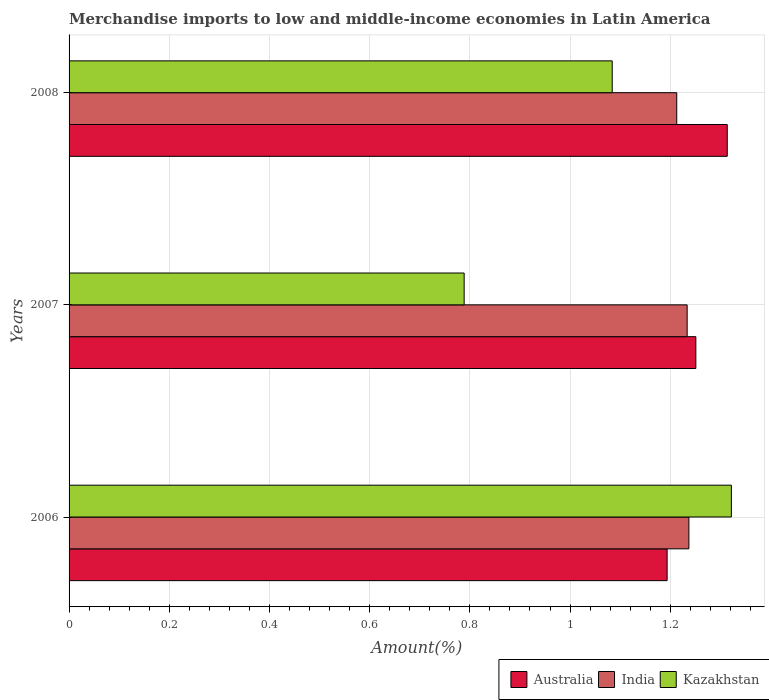How many different coloured bars are there?
Keep it short and to the point. 3. How many groups of bars are there?
Give a very brief answer. 3. Are the number of bars on each tick of the Y-axis equal?
Provide a short and direct response. Yes. How many bars are there on the 1st tick from the top?
Ensure brevity in your answer.  3. How many bars are there on the 2nd tick from the bottom?
Offer a very short reply. 3. In how many cases, is the number of bars for a given year not equal to the number of legend labels?
Keep it short and to the point. 0. What is the percentage of amount earned from merchandise imports in India in 2008?
Your answer should be compact. 1.21. Across all years, what is the maximum percentage of amount earned from merchandise imports in Kazakhstan?
Your response must be concise. 1.32. Across all years, what is the minimum percentage of amount earned from merchandise imports in Australia?
Offer a very short reply. 1.19. In which year was the percentage of amount earned from merchandise imports in Australia minimum?
Provide a succinct answer. 2006. What is the total percentage of amount earned from merchandise imports in Australia in the graph?
Ensure brevity in your answer.  3.76. What is the difference between the percentage of amount earned from merchandise imports in Kazakhstan in 2006 and that in 2008?
Provide a succinct answer. 0.24. What is the difference between the percentage of amount earned from merchandise imports in Australia in 2008 and the percentage of amount earned from merchandise imports in India in 2007?
Your answer should be compact. 0.08. What is the average percentage of amount earned from merchandise imports in Kazakhstan per year?
Ensure brevity in your answer.  1.06. In the year 2008, what is the difference between the percentage of amount earned from merchandise imports in Australia and percentage of amount earned from merchandise imports in Kazakhstan?
Offer a very short reply. 0.23. What is the ratio of the percentage of amount earned from merchandise imports in Kazakhstan in 2006 to that in 2007?
Provide a short and direct response. 1.68. Is the difference between the percentage of amount earned from merchandise imports in Australia in 2007 and 2008 greater than the difference between the percentage of amount earned from merchandise imports in Kazakhstan in 2007 and 2008?
Provide a short and direct response. Yes. What is the difference between the highest and the second highest percentage of amount earned from merchandise imports in Australia?
Provide a short and direct response. 0.06. What is the difference between the highest and the lowest percentage of amount earned from merchandise imports in Kazakhstan?
Your answer should be very brief. 0.53. What does the 3rd bar from the top in 2008 represents?
Your response must be concise. Australia. Does the graph contain any zero values?
Offer a terse response. No. Does the graph contain grids?
Give a very brief answer. Yes. Where does the legend appear in the graph?
Make the answer very short. Bottom right. How are the legend labels stacked?
Offer a terse response. Horizontal. What is the title of the graph?
Your answer should be very brief. Merchandise imports to low and middle-income economies in Latin America. What is the label or title of the X-axis?
Provide a succinct answer. Amount(%). What is the label or title of the Y-axis?
Ensure brevity in your answer.  Years. What is the Amount(%) in Australia in 2006?
Offer a very short reply. 1.19. What is the Amount(%) of India in 2006?
Offer a terse response. 1.24. What is the Amount(%) in Kazakhstan in 2006?
Ensure brevity in your answer.  1.32. What is the Amount(%) in Australia in 2007?
Your answer should be compact. 1.25. What is the Amount(%) of India in 2007?
Your answer should be compact. 1.23. What is the Amount(%) of Kazakhstan in 2007?
Offer a very short reply. 0.79. What is the Amount(%) of Australia in 2008?
Give a very brief answer. 1.31. What is the Amount(%) in India in 2008?
Your answer should be very brief. 1.21. What is the Amount(%) of Kazakhstan in 2008?
Offer a terse response. 1.08. Across all years, what is the maximum Amount(%) in Australia?
Your answer should be compact. 1.31. Across all years, what is the maximum Amount(%) in India?
Provide a succinct answer. 1.24. Across all years, what is the maximum Amount(%) of Kazakhstan?
Ensure brevity in your answer.  1.32. Across all years, what is the minimum Amount(%) of Australia?
Ensure brevity in your answer.  1.19. Across all years, what is the minimum Amount(%) of India?
Provide a succinct answer. 1.21. Across all years, what is the minimum Amount(%) in Kazakhstan?
Give a very brief answer. 0.79. What is the total Amount(%) in Australia in the graph?
Keep it short and to the point. 3.76. What is the total Amount(%) in India in the graph?
Keep it short and to the point. 3.68. What is the total Amount(%) in Kazakhstan in the graph?
Your answer should be compact. 3.19. What is the difference between the Amount(%) of Australia in 2006 and that in 2007?
Make the answer very short. -0.06. What is the difference between the Amount(%) of India in 2006 and that in 2007?
Make the answer very short. 0. What is the difference between the Amount(%) of Kazakhstan in 2006 and that in 2007?
Provide a short and direct response. 0.53. What is the difference between the Amount(%) of Australia in 2006 and that in 2008?
Offer a terse response. -0.12. What is the difference between the Amount(%) of India in 2006 and that in 2008?
Your answer should be very brief. 0.02. What is the difference between the Amount(%) in Kazakhstan in 2006 and that in 2008?
Offer a terse response. 0.24. What is the difference between the Amount(%) of Australia in 2007 and that in 2008?
Keep it short and to the point. -0.06. What is the difference between the Amount(%) in India in 2007 and that in 2008?
Ensure brevity in your answer.  0.02. What is the difference between the Amount(%) of Kazakhstan in 2007 and that in 2008?
Offer a very short reply. -0.3. What is the difference between the Amount(%) of Australia in 2006 and the Amount(%) of India in 2007?
Your answer should be very brief. -0.04. What is the difference between the Amount(%) in Australia in 2006 and the Amount(%) in Kazakhstan in 2007?
Give a very brief answer. 0.41. What is the difference between the Amount(%) of India in 2006 and the Amount(%) of Kazakhstan in 2007?
Provide a short and direct response. 0.45. What is the difference between the Amount(%) of Australia in 2006 and the Amount(%) of India in 2008?
Give a very brief answer. -0.02. What is the difference between the Amount(%) in Australia in 2006 and the Amount(%) in Kazakhstan in 2008?
Make the answer very short. 0.11. What is the difference between the Amount(%) of India in 2006 and the Amount(%) of Kazakhstan in 2008?
Offer a very short reply. 0.15. What is the difference between the Amount(%) in Australia in 2007 and the Amount(%) in India in 2008?
Keep it short and to the point. 0.04. What is the difference between the Amount(%) of Australia in 2007 and the Amount(%) of Kazakhstan in 2008?
Your answer should be compact. 0.17. What is the difference between the Amount(%) of India in 2007 and the Amount(%) of Kazakhstan in 2008?
Your response must be concise. 0.15. What is the average Amount(%) in Australia per year?
Give a very brief answer. 1.25. What is the average Amount(%) of India per year?
Keep it short and to the point. 1.23. What is the average Amount(%) of Kazakhstan per year?
Make the answer very short. 1.06. In the year 2006, what is the difference between the Amount(%) of Australia and Amount(%) of India?
Keep it short and to the point. -0.04. In the year 2006, what is the difference between the Amount(%) in Australia and Amount(%) in Kazakhstan?
Make the answer very short. -0.13. In the year 2006, what is the difference between the Amount(%) in India and Amount(%) in Kazakhstan?
Offer a very short reply. -0.08. In the year 2007, what is the difference between the Amount(%) of Australia and Amount(%) of India?
Ensure brevity in your answer.  0.02. In the year 2007, what is the difference between the Amount(%) in Australia and Amount(%) in Kazakhstan?
Offer a terse response. 0.46. In the year 2007, what is the difference between the Amount(%) of India and Amount(%) of Kazakhstan?
Offer a very short reply. 0.45. In the year 2008, what is the difference between the Amount(%) in Australia and Amount(%) in India?
Offer a very short reply. 0.1. In the year 2008, what is the difference between the Amount(%) of Australia and Amount(%) of Kazakhstan?
Make the answer very short. 0.23. In the year 2008, what is the difference between the Amount(%) in India and Amount(%) in Kazakhstan?
Your answer should be very brief. 0.13. What is the ratio of the Amount(%) in Australia in 2006 to that in 2007?
Give a very brief answer. 0.95. What is the ratio of the Amount(%) of India in 2006 to that in 2007?
Ensure brevity in your answer.  1. What is the ratio of the Amount(%) of Kazakhstan in 2006 to that in 2007?
Your response must be concise. 1.68. What is the ratio of the Amount(%) of Australia in 2006 to that in 2008?
Provide a succinct answer. 0.91. What is the ratio of the Amount(%) of Kazakhstan in 2006 to that in 2008?
Your answer should be very brief. 1.22. What is the ratio of the Amount(%) of Australia in 2007 to that in 2008?
Make the answer very short. 0.95. What is the ratio of the Amount(%) in India in 2007 to that in 2008?
Your response must be concise. 1.02. What is the ratio of the Amount(%) of Kazakhstan in 2007 to that in 2008?
Offer a terse response. 0.73. What is the difference between the highest and the second highest Amount(%) in Australia?
Your response must be concise. 0.06. What is the difference between the highest and the second highest Amount(%) of India?
Offer a very short reply. 0. What is the difference between the highest and the second highest Amount(%) of Kazakhstan?
Ensure brevity in your answer.  0.24. What is the difference between the highest and the lowest Amount(%) in Australia?
Provide a succinct answer. 0.12. What is the difference between the highest and the lowest Amount(%) of India?
Your response must be concise. 0.02. What is the difference between the highest and the lowest Amount(%) in Kazakhstan?
Offer a terse response. 0.53. 